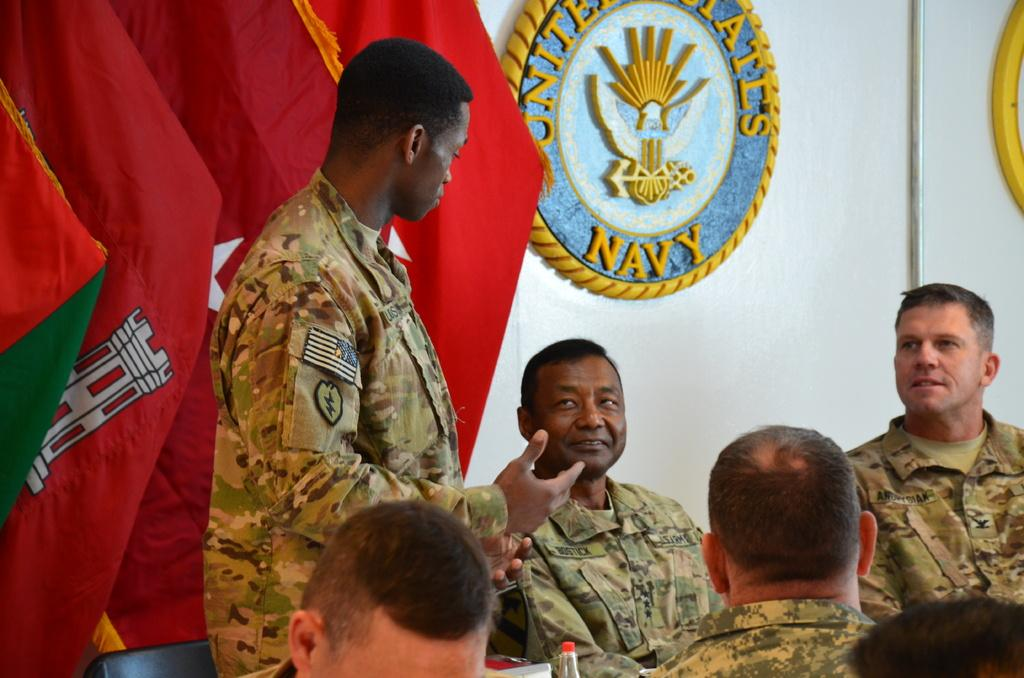What is located in the foreground of the image? There is a group of people in the foreground of the image. What can be seen in the background of the image? There are flags and an emblem in the background of the image. What is written or depicted around the emblem? There is text surrounding the emblem in the background of the image. How many squares are present in the image? There is no square present in the image. Can you describe the land in the image? There is no reference to land in the image; it features a group of people in the foreground and flags and an emblem in the background. 